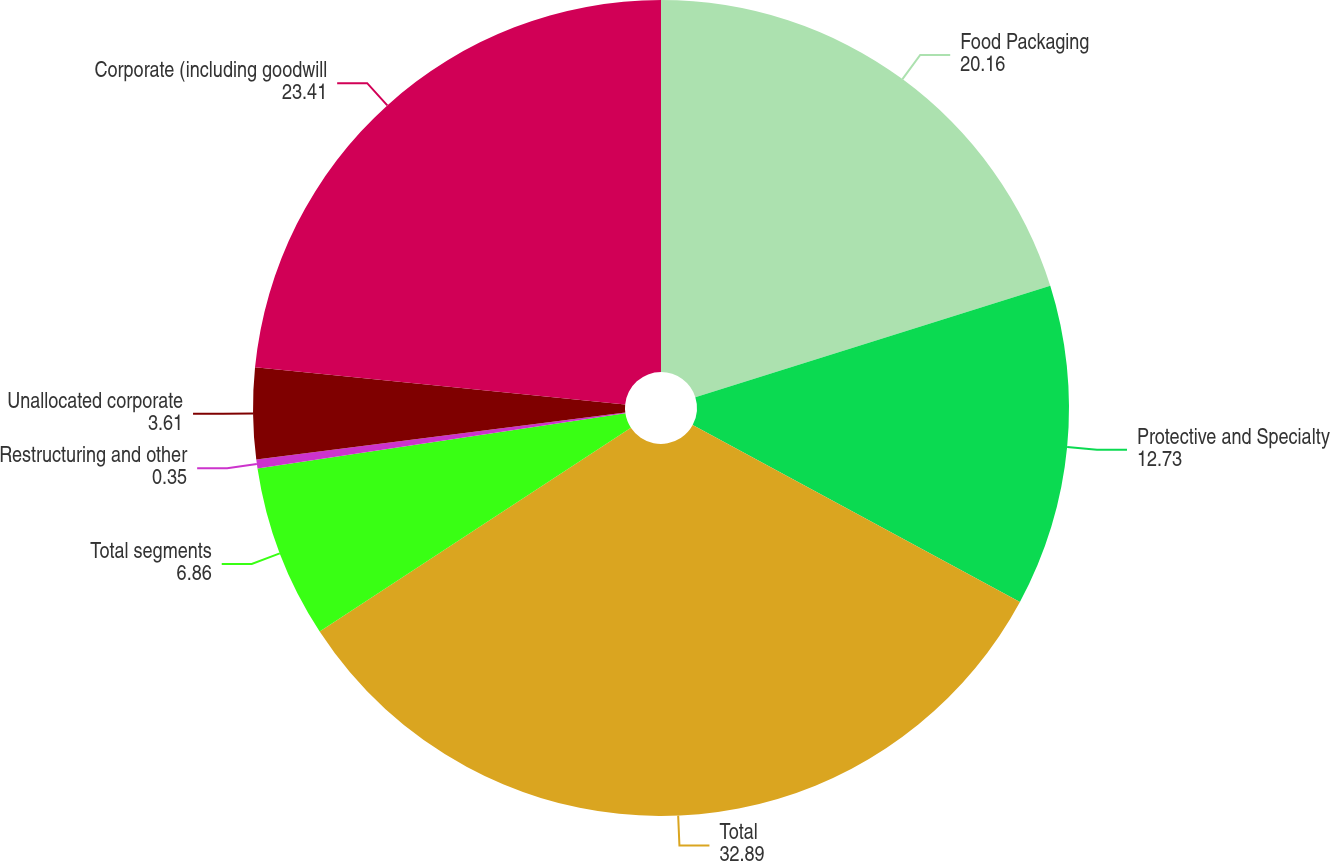<chart> <loc_0><loc_0><loc_500><loc_500><pie_chart><fcel>Food Packaging<fcel>Protective and Specialty<fcel>Total<fcel>Total segments<fcel>Restructuring and other<fcel>Unallocated corporate<fcel>Corporate (including goodwill<nl><fcel>20.16%<fcel>12.73%<fcel>32.89%<fcel>6.86%<fcel>0.35%<fcel>3.61%<fcel>23.41%<nl></chart> 